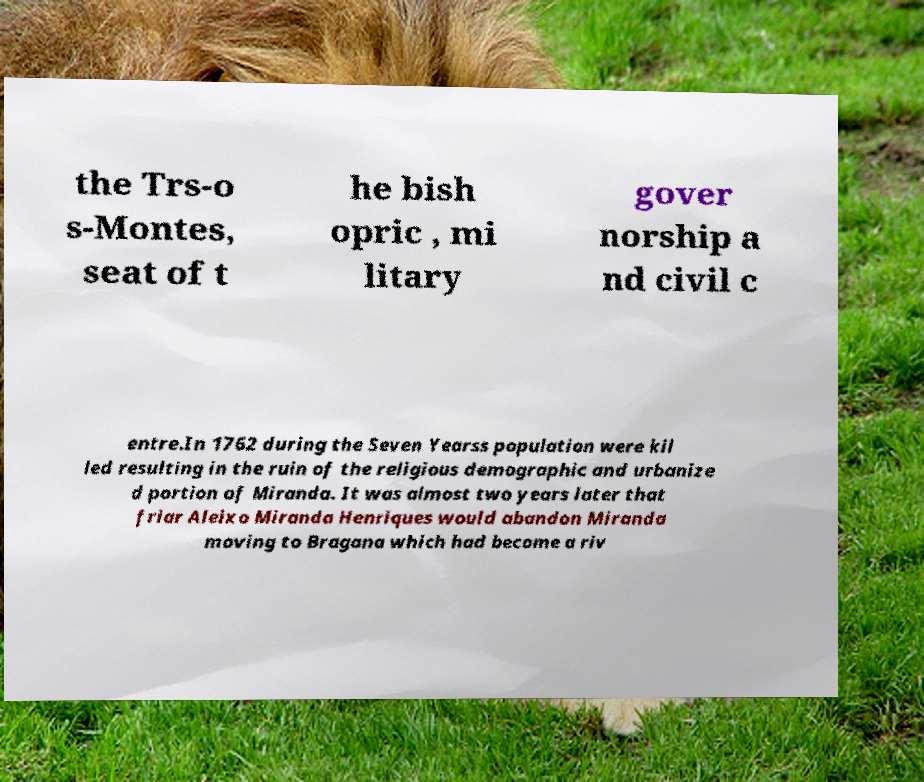Please identify and transcribe the text found in this image. the Trs-o s-Montes, seat of t he bish opric , mi litary gover norship a nd civil c entre.In 1762 during the Seven Yearss population were kil led resulting in the ruin of the religious demographic and urbanize d portion of Miranda. It was almost two years later that friar Aleixo Miranda Henriques would abandon Miranda moving to Bragana which had become a riv 